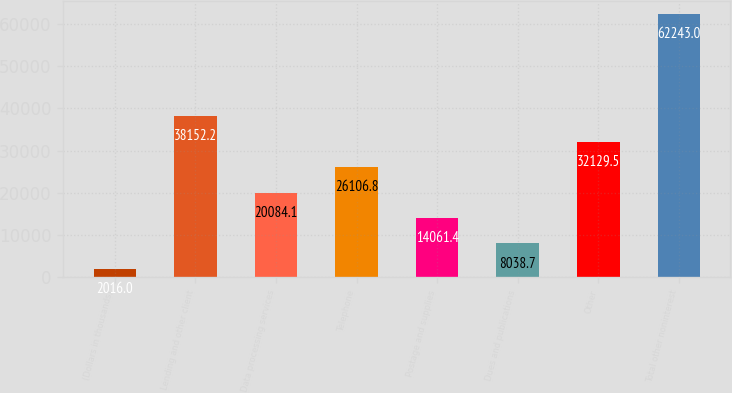<chart> <loc_0><loc_0><loc_500><loc_500><bar_chart><fcel>(Dollars in thousands)<fcel>Lending and other client<fcel>Data processing services<fcel>Telephone<fcel>Postage and supplies<fcel>Dues and publications<fcel>Other<fcel>Total other noninterest<nl><fcel>2016<fcel>38152.2<fcel>20084.1<fcel>26106.8<fcel>14061.4<fcel>8038.7<fcel>32129.5<fcel>62243<nl></chart> 